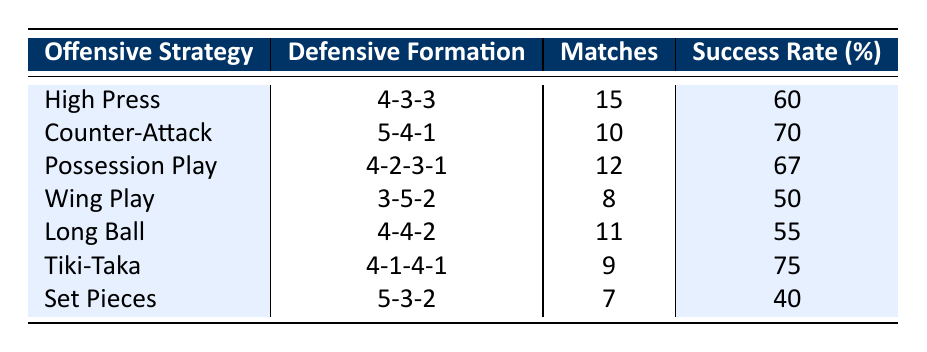What is the success rate of the High Press offensive strategy? The table shows that the High Press offensive strategy has a success rate of 60%.
Answer: 60% Which defensive formation is associated with the highest success rate? Looking at the success rates in the table, Tiki-Taka with a 4-1-4-1 formation has the highest success rate at 75%.
Answer: Tiki-Taka (4-1-4-1) How many matches utilized the Wing Play strategy? The table indicates that the Wing Play strategy was utilized in 8 matches.
Answer: 8 What is the average success rate of the offensive strategies listed? To find the average, sum the success rates (60 + 70 + 67 + 50 + 55 + 75 + 40 = 417) and divide by the number of strategies (7). The average is 417 / 7 ≈ 59.71.
Answer: Approximately 59.71 Is it true that the Counter-Attack strategy was used in more matches than the Set Pieces strategy? Yes, the Counter-Attack strategy was used in 10 matches while Set Pieces was only used in 7 matches.
Answer: Yes What is the difference in success rates between Counter-Attack and Long Ball strategies? Counter-Attack has a success rate of 70%, while Long Ball has 55%. The difference is 70 - 55 = 15 percentage points.
Answer: 15 Considering all strategies, how many matches had a success rate above 60%? The strategies with success rates above 60% are High Press (60%), Counter-Attack (70%), Possession Play (67%), and Tiki-Taka (75%), totaling 4 strategies.
Answer: 4 